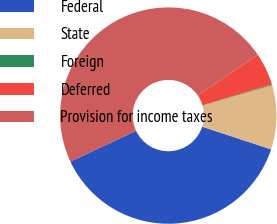Convert chart to OTSL. <chart><loc_0><loc_0><loc_500><loc_500><pie_chart><fcel>Federal<fcel>State<fcel>Foreign<fcel>Deferred<fcel>Provision for income taxes<nl><fcel>37.95%<fcel>9.59%<fcel>0.12%<fcel>4.86%<fcel>47.47%<nl></chart> 